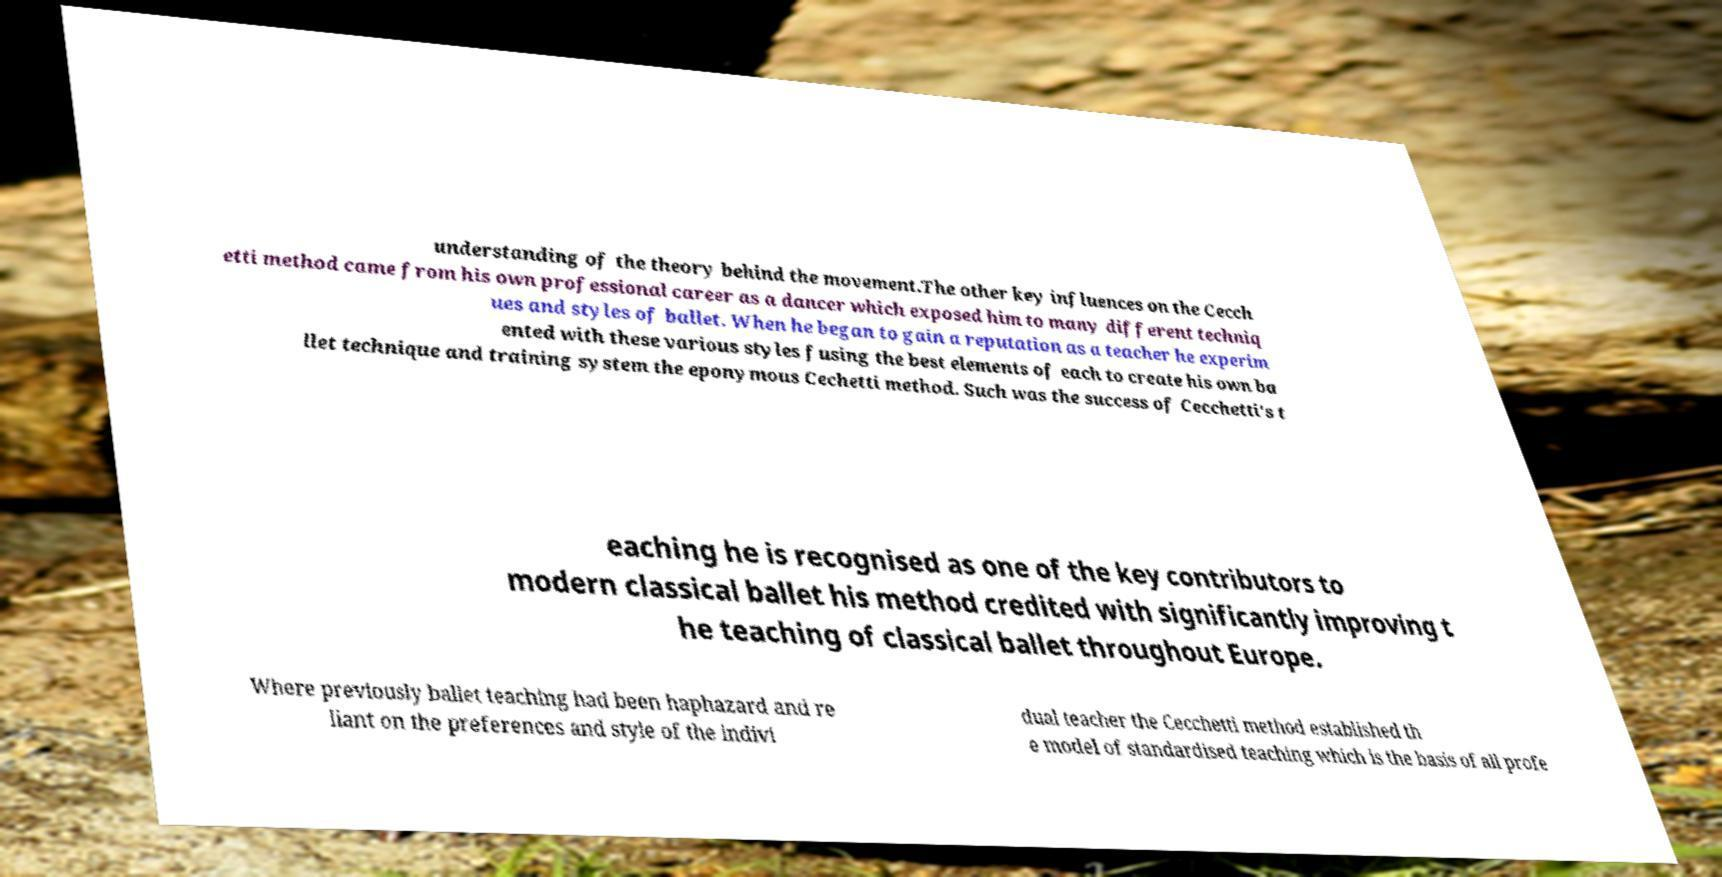Can you accurately transcribe the text from the provided image for me? understanding of the theory behind the movement.The other key influences on the Cecch etti method came from his own professional career as a dancer which exposed him to many different techniq ues and styles of ballet. When he began to gain a reputation as a teacher he experim ented with these various styles fusing the best elements of each to create his own ba llet technique and training system the eponymous Cechetti method. Such was the success of Cecchetti's t eaching he is recognised as one of the key contributors to modern classical ballet his method credited with significantly improving t he teaching of classical ballet throughout Europe. Where previously ballet teaching had been haphazard and re liant on the preferences and style of the indivi dual teacher the Cecchetti method established th e model of standardised teaching which is the basis of all profe 